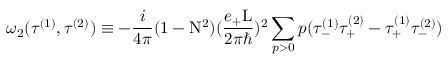<formula> <loc_0><loc_0><loc_500><loc_500>{ \omega } _ { 2 } ( { \tau } ^ { ( 1 ) } , { \tau } ^ { ( 2 ) } ) \equiv - \frac { i } { 4 \pi } ( 1 - N ^ { 2 } ) ( \frac { e _ { + } L } { 2 { \pi } { } } ) ^ { 2 } \sum _ { p > 0 } p ( { \tau } _ { - } ^ { ( 1 ) } { \tau } _ { + } ^ { ( 2 ) } - { \tau } _ { + } ^ { ( 1 ) } { \tau } _ { - } ^ { ( 2 ) } )</formula> 